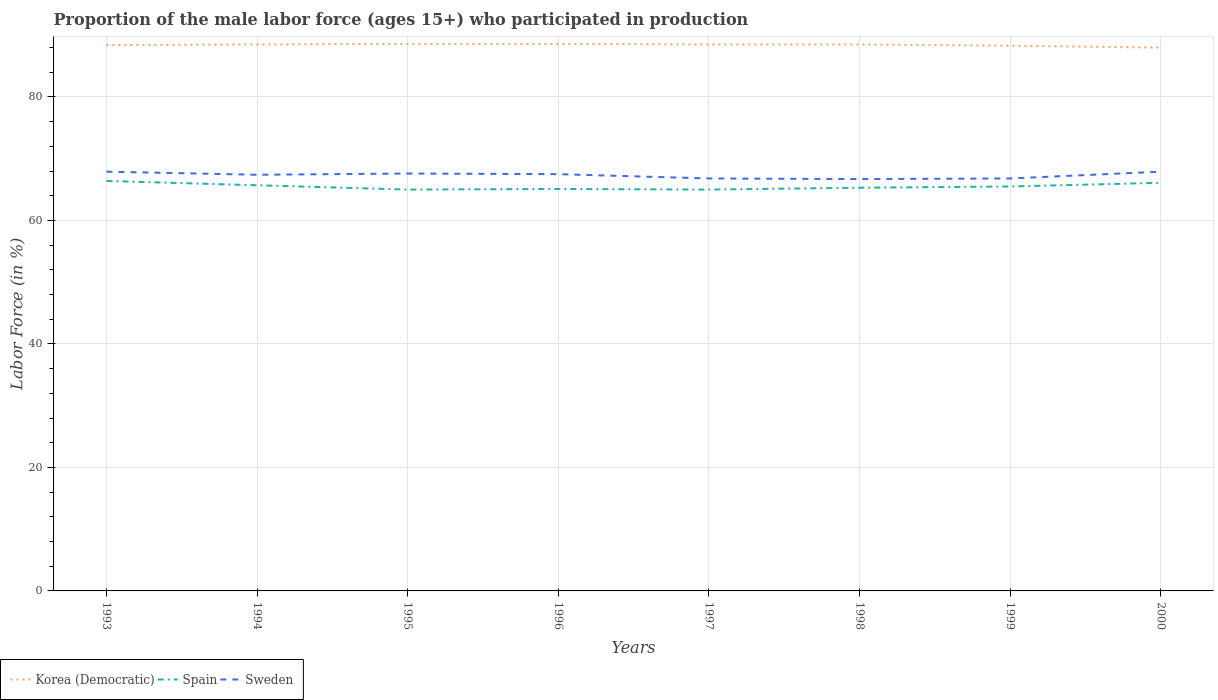Does the line corresponding to Korea (Democratic) intersect with the line corresponding to Spain?
Make the answer very short. No. Across all years, what is the maximum proportion of the male labor force who participated in production in Korea (Democratic)?
Provide a short and direct response. 88. What is the total proportion of the male labor force who participated in production in Korea (Democratic) in the graph?
Offer a terse response. -0.1. What is the difference between the highest and the second highest proportion of the male labor force who participated in production in Korea (Democratic)?
Your response must be concise. 0.6. What is the difference between the highest and the lowest proportion of the male labor force who participated in production in Sweden?
Ensure brevity in your answer.  5. How many lines are there?
Provide a succinct answer. 3. How many years are there in the graph?
Ensure brevity in your answer.  8. What is the difference between two consecutive major ticks on the Y-axis?
Provide a succinct answer. 20. Are the values on the major ticks of Y-axis written in scientific E-notation?
Ensure brevity in your answer.  No. Does the graph contain any zero values?
Offer a terse response. No. How many legend labels are there?
Your answer should be compact. 3. How are the legend labels stacked?
Your answer should be compact. Horizontal. What is the title of the graph?
Keep it short and to the point. Proportion of the male labor force (ages 15+) who participated in production. What is the label or title of the Y-axis?
Offer a terse response. Labor Force (in %). What is the Labor Force (in %) in Korea (Democratic) in 1993?
Offer a very short reply. 88.4. What is the Labor Force (in %) of Spain in 1993?
Keep it short and to the point. 66.4. What is the Labor Force (in %) in Sweden in 1993?
Offer a very short reply. 67.9. What is the Labor Force (in %) in Korea (Democratic) in 1994?
Make the answer very short. 88.5. What is the Labor Force (in %) of Spain in 1994?
Make the answer very short. 65.7. What is the Labor Force (in %) in Sweden in 1994?
Keep it short and to the point. 67.4. What is the Labor Force (in %) of Korea (Democratic) in 1995?
Your answer should be compact. 88.6. What is the Labor Force (in %) in Sweden in 1995?
Offer a terse response. 67.6. What is the Labor Force (in %) in Korea (Democratic) in 1996?
Ensure brevity in your answer.  88.6. What is the Labor Force (in %) in Spain in 1996?
Keep it short and to the point. 65.1. What is the Labor Force (in %) in Sweden in 1996?
Keep it short and to the point. 67.5. What is the Labor Force (in %) of Korea (Democratic) in 1997?
Your answer should be compact. 88.5. What is the Labor Force (in %) of Sweden in 1997?
Ensure brevity in your answer.  66.8. What is the Labor Force (in %) of Korea (Democratic) in 1998?
Provide a short and direct response. 88.5. What is the Labor Force (in %) of Spain in 1998?
Keep it short and to the point. 65.3. What is the Labor Force (in %) in Sweden in 1998?
Ensure brevity in your answer.  66.7. What is the Labor Force (in %) in Korea (Democratic) in 1999?
Give a very brief answer. 88.3. What is the Labor Force (in %) of Spain in 1999?
Your answer should be very brief. 65.5. What is the Labor Force (in %) of Sweden in 1999?
Provide a short and direct response. 66.8. What is the Labor Force (in %) in Korea (Democratic) in 2000?
Offer a very short reply. 88. What is the Labor Force (in %) of Spain in 2000?
Offer a terse response. 66.1. What is the Labor Force (in %) in Sweden in 2000?
Offer a terse response. 67.9. Across all years, what is the maximum Labor Force (in %) of Korea (Democratic)?
Ensure brevity in your answer.  88.6. Across all years, what is the maximum Labor Force (in %) in Spain?
Offer a terse response. 66.4. Across all years, what is the maximum Labor Force (in %) of Sweden?
Give a very brief answer. 67.9. Across all years, what is the minimum Labor Force (in %) in Korea (Democratic)?
Provide a short and direct response. 88. Across all years, what is the minimum Labor Force (in %) in Sweden?
Keep it short and to the point. 66.7. What is the total Labor Force (in %) in Korea (Democratic) in the graph?
Offer a terse response. 707.4. What is the total Labor Force (in %) of Spain in the graph?
Offer a very short reply. 524.1. What is the total Labor Force (in %) in Sweden in the graph?
Your answer should be compact. 538.6. What is the difference between the Labor Force (in %) of Korea (Democratic) in 1993 and that in 1994?
Make the answer very short. -0.1. What is the difference between the Labor Force (in %) in Spain in 1993 and that in 1994?
Make the answer very short. 0.7. What is the difference between the Labor Force (in %) in Spain in 1993 and that in 1995?
Offer a terse response. 1.4. What is the difference between the Labor Force (in %) of Sweden in 1993 and that in 1995?
Ensure brevity in your answer.  0.3. What is the difference between the Labor Force (in %) in Sweden in 1993 and that in 1996?
Your response must be concise. 0.4. What is the difference between the Labor Force (in %) in Spain in 1993 and that in 1997?
Your answer should be very brief. 1.4. What is the difference between the Labor Force (in %) of Sweden in 1993 and that in 1997?
Your answer should be very brief. 1.1. What is the difference between the Labor Force (in %) of Spain in 1993 and that in 1998?
Make the answer very short. 1.1. What is the difference between the Labor Force (in %) in Korea (Democratic) in 1993 and that in 1999?
Provide a short and direct response. 0.1. What is the difference between the Labor Force (in %) in Spain in 1993 and that in 1999?
Your response must be concise. 0.9. What is the difference between the Labor Force (in %) of Sweden in 1993 and that in 1999?
Provide a short and direct response. 1.1. What is the difference between the Labor Force (in %) of Sweden in 1993 and that in 2000?
Provide a short and direct response. 0. What is the difference between the Labor Force (in %) in Spain in 1994 and that in 1995?
Offer a terse response. 0.7. What is the difference between the Labor Force (in %) in Korea (Democratic) in 1994 and that in 1996?
Keep it short and to the point. -0.1. What is the difference between the Labor Force (in %) of Spain in 1994 and that in 1996?
Offer a very short reply. 0.6. What is the difference between the Labor Force (in %) in Korea (Democratic) in 1994 and that in 1997?
Provide a succinct answer. 0. What is the difference between the Labor Force (in %) in Spain in 1994 and that in 1997?
Ensure brevity in your answer.  0.7. What is the difference between the Labor Force (in %) in Sweden in 1994 and that in 1997?
Provide a succinct answer. 0.6. What is the difference between the Labor Force (in %) of Korea (Democratic) in 1994 and that in 1998?
Your answer should be very brief. 0. What is the difference between the Labor Force (in %) of Spain in 1994 and that in 1998?
Provide a succinct answer. 0.4. What is the difference between the Labor Force (in %) of Spain in 1994 and that in 1999?
Keep it short and to the point. 0.2. What is the difference between the Labor Force (in %) in Sweden in 1994 and that in 1999?
Keep it short and to the point. 0.6. What is the difference between the Labor Force (in %) of Spain in 1995 and that in 1996?
Your answer should be compact. -0.1. What is the difference between the Labor Force (in %) in Sweden in 1995 and that in 1996?
Ensure brevity in your answer.  0.1. What is the difference between the Labor Force (in %) of Spain in 1995 and that in 1997?
Offer a terse response. 0. What is the difference between the Labor Force (in %) of Korea (Democratic) in 1995 and that in 1998?
Offer a terse response. 0.1. What is the difference between the Labor Force (in %) of Spain in 1995 and that in 1998?
Your response must be concise. -0.3. What is the difference between the Labor Force (in %) in Korea (Democratic) in 1995 and that in 1999?
Provide a short and direct response. 0.3. What is the difference between the Labor Force (in %) in Sweden in 1995 and that in 1999?
Provide a short and direct response. 0.8. What is the difference between the Labor Force (in %) in Korea (Democratic) in 1995 and that in 2000?
Your answer should be compact. 0.6. What is the difference between the Labor Force (in %) of Sweden in 1995 and that in 2000?
Give a very brief answer. -0.3. What is the difference between the Labor Force (in %) in Spain in 1996 and that in 1997?
Ensure brevity in your answer.  0.1. What is the difference between the Labor Force (in %) in Korea (Democratic) in 1996 and that in 1998?
Your response must be concise. 0.1. What is the difference between the Labor Force (in %) in Spain in 1996 and that in 1998?
Offer a terse response. -0.2. What is the difference between the Labor Force (in %) of Sweden in 1996 and that in 1998?
Keep it short and to the point. 0.8. What is the difference between the Labor Force (in %) of Sweden in 1996 and that in 1999?
Offer a very short reply. 0.7. What is the difference between the Labor Force (in %) of Korea (Democratic) in 1996 and that in 2000?
Make the answer very short. 0.6. What is the difference between the Labor Force (in %) in Spain in 1996 and that in 2000?
Offer a very short reply. -1. What is the difference between the Labor Force (in %) of Korea (Democratic) in 1997 and that in 1998?
Keep it short and to the point. 0. What is the difference between the Labor Force (in %) of Sweden in 1997 and that in 1999?
Ensure brevity in your answer.  0. What is the difference between the Labor Force (in %) of Korea (Democratic) in 1998 and that in 1999?
Your answer should be compact. 0.2. What is the difference between the Labor Force (in %) of Spain in 1998 and that in 1999?
Your answer should be very brief. -0.2. What is the difference between the Labor Force (in %) in Sweden in 1998 and that in 2000?
Keep it short and to the point. -1.2. What is the difference between the Labor Force (in %) of Korea (Democratic) in 1999 and that in 2000?
Make the answer very short. 0.3. What is the difference between the Labor Force (in %) in Sweden in 1999 and that in 2000?
Ensure brevity in your answer.  -1.1. What is the difference between the Labor Force (in %) of Korea (Democratic) in 1993 and the Labor Force (in %) of Spain in 1994?
Give a very brief answer. 22.7. What is the difference between the Labor Force (in %) in Korea (Democratic) in 1993 and the Labor Force (in %) in Sweden in 1994?
Your answer should be compact. 21. What is the difference between the Labor Force (in %) of Korea (Democratic) in 1993 and the Labor Force (in %) of Spain in 1995?
Give a very brief answer. 23.4. What is the difference between the Labor Force (in %) in Korea (Democratic) in 1993 and the Labor Force (in %) in Sweden in 1995?
Offer a very short reply. 20.8. What is the difference between the Labor Force (in %) in Korea (Democratic) in 1993 and the Labor Force (in %) in Spain in 1996?
Make the answer very short. 23.3. What is the difference between the Labor Force (in %) of Korea (Democratic) in 1993 and the Labor Force (in %) of Sweden in 1996?
Keep it short and to the point. 20.9. What is the difference between the Labor Force (in %) in Korea (Democratic) in 1993 and the Labor Force (in %) in Spain in 1997?
Give a very brief answer. 23.4. What is the difference between the Labor Force (in %) in Korea (Democratic) in 1993 and the Labor Force (in %) in Sweden in 1997?
Offer a terse response. 21.6. What is the difference between the Labor Force (in %) of Spain in 1993 and the Labor Force (in %) of Sweden in 1997?
Your answer should be compact. -0.4. What is the difference between the Labor Force (in %) of Korea (Democratic) in 1993 and the Labor Force (in %) of Spain in 1998?
Provide a short and direct response. 23.1. What is the difference between the Labor Force (in %) of Korea (Democratic) in 1993 and the Labor Force (in %) of Sweden in 1998?
Offer a terse response. 21.7. What is the difference between the Labor Force (in %) in Spain in 1993 and the Labor Force (in %) in Sweden in 1998?
Give a very brief answer. -0.3. What is the difference between the Labor Force (in %) in Korea (Democratic) in 1993 and the Labor Force (in %) in Spain in 1999?
Your answer should be very brief. 22.9. What is the difference between the Labor Force (in %) in Korea (Democratic) in 1993 and the Labor Force (in %) in Sweden in 1999?
Your answer should be very brief. 21.6. What is the difference between the Labor Force (in %) of Spain in 1993 and the Labor Force (in %) of Sweden in 1999?
Offer a very short reply. -0.4. What is the difference between the Labor Force (in %) in Korea (Democratic) in 1993 and the Labor Force (in %) in Spain in 2000?
Your answer should be very brief. 22.3. What is the difference between the Labor Force (in %) of Korea (Democratic) in 1994 and the Labor Force (in %) of Spain in 1995?
Offer a terse response. 23.5. What is the difference between the Labor Force (in %) of Korea (Democratic) in 1994 and the Labor Force (in %) of Sweden in 1995?
Your answer should be compact. 20.9. What is the difference between the Labor Force (in %) in Korea (Democratic) in 1994 and the Labor Force (in %) in Spain in 1996?
Give a very brief answer. 23.4. What is the difference between the Labor Force (in %) in Korea (Democratic) in 1994 and the Labor Force (in %) in Spain in 1997?
Give a very brief answer. 23.5. What is the difference between the Labor Force (in %) of Korea (Democratic) in 1994 and the Labor Force (in %) of Sweden in 1997?
Your response must be concise. 21.7. What is the difference between the Labor Force (in %) of Korea (Democratic) in 1994 and the Labor Force (in %) of Spain in 1998?
Your answer should be very brief. 23.2. What is the difference between the Labor Force (in %) of Korea (Democratic) in 1994 and the Labor Force (in %) of Sweden in 1998?
Offer a terse response. 21.8. What is the difference between the Labor Force (in %) of Spain in 1994 and the Labor Force (in %) of Sweden in 1998?
Ensure brevity in your answer.  -1. What is the difference between the Labor Force (in %) in Korea (Democratic) in 1994 and the Labor Force (in %) in Spain in 1999?
Your answer should be compact. 23. What is the difference between the Labor Force (in %) of Korea (Democratic) in 1994 and the Labor Force (in %) of Sweden in 1999?
Provide a succinct answer. 21.7. What is the difference between the Labor Force (in %) in Spain in 1994 and the Labor Force (in %) in Sweden in 1999?
Your answer should be compact. -1.1. What is the difference between the Labor Force (in %) of Korea (Democratic) in 1994 and the Labor Force (in %) of Spain in 2000?
Make the answer very short. 22.4. What is the difference between the Labor Force (in %) of Korea (Democratic) in 1994 and the Labor Force (in %) of Sweden in 2000?
Offer a very short reply. 20.6. What is the difference between the Labor Force (in %) in Korea (Democratic) in 1995 and the Labor Force (in %) in Spain in 1996?
Provide a short and direct response. 23.5. What is the difference between the Labor Force (in %) in Korea (Democratic) in 1995 and the Labor Force (in %) in Sweden in 1996?
Make the answer very short. 21.1. What is the difference between the Labor Force (in %) of Spain in 1995 and the Labor Force (in %) of Sweden in 1996?
Your response must be concise. -2.5. What is the difference between the Labor Force (in %) of Korea (Democratic) in 1995 and the Labor Force (in %) of Spain in 1997?
Make the answer very short. 23.6. What is the difference between the Labor Force (in %) of Korea (Democratic) in 1995 and the Labor Force (in %) of Sweden in 1997?
Make the answer very short. 21.8. What is the difference between the Labor Force (in %) of Korea (Democratic) in 1995 and the Labor Force (in %) of Spain in 1998?
Keep it short and to the point. 23.3. What is the difference between the Labor Force (in %) in Korea (Democratic) in 1995 and the Labor Force (in %) in Sweden in 1998?
Keep it short and to the point. 21.9. What is the difference between the Labor Force (in %) in Korea (Democratic) in 1995 and the Labor Force (in %) in Spain in 1999?
Provide a short and direct response. 23.1. What is the difference between the Labor Force (in %) of Korea (Democratic) in 1995 and the Labor Force (in %) of Sweden in 1999?
Provide a short and direct response. 21.8. What is the difference between the Labor Force (in %) of Spain in 1995 and the Labor Force (in %) of Sweden in 1999?
Provide a short and direct response. -1.8. What is the difference between the Labor Force (in %) in Korea (Democratic) in 1995 and the Labor Force (in %) in Sweden in 2000?
Your response must be concise. 20.7. What is the difference between the Labor Force (in %) in Korea (Democratic) in 1996 and the Labor Force (in %) in Spain in 1997?
Your answer should be very brief. 23.6. What is the difference between the Labor Force (in %) of Korea (Democratic) in 1996 and the Labor Force (in %) of Sweden in 1997?
Your answer should be compact. 21.8. What is the difference between the Labor Force (in %) of Korea (Democratic) in 1996 and the Labor Force (in %) of Spain in 1998?
Your response must be concise. 23.3. What is the difference between the Labor Force (in %) of Korea (Democratic) in 1996 and the Labor Force (in %) of Sweden in 1998?
Offer a terse response. 21.9. What is the difference between the Labor Force (in %) of Spain in 1996 and the Labor Force (in %) of Sweden in 1998?
Offer a terse response. -1.6. What is the difference between the Labor Force (in %) in Korea (Democratic) in 1996 and the Labor Force (in %) in Spain in 1999?
Make the answer very short. 23.1. What is the difference between the Labor Force (in %) in Korea (Democratic) in 1996 and the Labor Force (in %) in Sweden in 1999?
Make the answer very short. 21.8. What is the difference between the Labor Force (in %) in Spain in 1996 and the Labor Force (in %) in Sweden in 1999?
Provide a succinct answer. -1.7. What is the difference between the Labor Force (in %) of Korea (Democratic) in 1996 and the Labor Force (in %) of Sweden in 2000?
Offer a terse response. 20.7. What is the difference between the Labor Force (in %) of Spain in 1996 and the Labor Force (in %) of Sweden in 2000?
Keep it short and to the point. -2.8. What is the difference between the Labor Force (in %) of Korea (Democratic) in 1997 and the Labor Force (in %) of Spain in 1998?
Make the answer very short. 23.2. What is the difference between the Labor Force (in %) in Korea (Democratic) in 1997 and the Labor Force (in %) in Sweden in 1998?
Provide a succinct answer. 21.8. What is the difference between the Labor Force (in %) of Korea (Democratic) in 1997 and the Labor Force (in %) of Spain in 1999?
Keep it short and to the point. 23. What is the difference between the Labor Force (in %) of Korea (Democratic) in 1997 and the Labor Force (in %) of Sweden in 1999?
Your answer should be compact. 21.7. What is the difference between the Labor Force (in %) in Spain in 1997 and the Labor Force (in %) in Sweden in 1999?
Give a very brief answer. -1.8. What is the difference between the Labor Force (in %) in Korea (Democratic) in 1997 and the Labor Force (in %) in Spain in 2000?
Provide a succinct answer. 22.4. What is the difference between the Labor Force (in %) of Korea (Democratic) in 1997 and the Labor Force (in %) of Sweden in 2000?
Offer a very short reply. 20.6. What is the difference between the Labor Force (in %) in Korea (Democratic) in 1998 and the Labor Force (in %) in Spain in 1999?
Ensure brevity in your answer.  23. What is the difference between the Labor Force (in %) in Korea (Democratic) in 1998 and the Labor Force (in %) in Sweden in 1999?
Ensure brevity in your answer.  21.7. What is the difference between the Labor Force (in %) of Spain in 1998 and the Labor Force (in %) of Sweden in 1999?
Give a very brief answer. -1.5. What is the difference between the Labor Force (in %) of Korea (Democratic) in 1998 and the Labor Force (in %) of Spain in 2000?
Provide a succinct answer. 22.4. What is the difference between the Labor Force (in %) in Korea (Democratic) in 1998 and the Labor Force (in %) in Sweden in 2000?
Ensure brevity in your answer.  20.6. What is the difference between the Labor Force (in %) in Korea (Democratic) in 1999 and the Labor Force (in %) in Spain in 2000?
Keep it short and to the point. 22.2. What is the difference between the Labor Force (in %) in Korea (Democratic) in 1999 and the Labor Force (in %) in Sweden in 2000?
Make the answer very short. 20.4. What is the difference between the Labor Force (in %) in Spain in 1999 and the Labor Force (in %) in Sweden in 2000?
Make the answer very short. -2.4. What is the average Labor Force (in %) in Korea (Democratic) per year?
Provide a succinct answer. 88.42. What is the average Labor Force (in %) in Spain per year?
Ensure brevity in your answer.  65.51. What is the average Labor Force (in %) in Sweden per year?
Provide a short and direct response. 67.33. In the year 1993, what is the difference between the Labor Force (in %) in Korea (Democratic) and Labor Force (in %) in Spain?
Provide a succinct answer. 22. In the year 1994, what is the difference between the Labor Force (in %) of Korea (Democratic) and Labor Force (in %) of Spain?
Provide a short and direct response. 22.8. In the year 1994, what is the difference between the Labor Force (in %) in Korea (Democratic) and Labor Force (in %) in Sweden?
Keep it short and to the point. 21.1. In the year 1995, what is the difference between the Labor Force (in %) in Korea (Democratic) and Labor Force (in %) in Spain?
Offer a terse response. 23.6. In the year 1995, what is the difference between the Labor Force (in %) in Spain and Labor Force (in %) in Sweden?
Your response must be concise. -2.6. In the year 1996, what is the difference between the Labor Force (in %) of Korea (Democratic) and Labor Force (in %) of Sweden?
Make the answer very short. 21.1. In the year 1997, what is the difference between the Labor Force (in %) in Korea (Democratic) and Labor Force (in %) in Spain?
Your response must be concise. 23.5. In the year 1997, what is the difference between the Labor Force (in %) of Korea (Democratic) and Labor Force (in %) of Sweden?
Your answer should be very brief. 21.7. In the year 1998, what is the difference between the Labor Force (in %) of Korea (Democratic) and Labor Force (in %) of Spain?
Ensure brevity in your answer.  23.2. In the year 1998, what is the difference between the Labor Force (in %) of Korea (Democratic) and Labor Force (in %) of Sweden?
Ensure brevity in your answer.  21.8. In the year 1998, what is the difference between the Labor Force (in %) of Spain and Labor Force (in %) of Sweden?
Make the answer very short. -1.4. In the year 1999, what is the difference between the Labor Force (in %) of Korea (Democratic) and Labor Force (in %) of Spain?
Ensure brevity in your answer.  22.8. In the year 1999, what is the difference between the Labor Force (in %) of Spain and Labor Force (in %) of Sweden?
Make the answer very short. -1.3. In the year 2000, what is the difference between the Labor Force (in %) in Korea (Democratic) and Labor Force (in %) in Spain?
Provide a succinct answer. 21.9. In the year 2000, what is the difference between the Labor Force (in %) of Korea (Democratic) and Labor Force (in %) of Sweden?
Your answer should be compact. 20.1. What is the ratio of the Labor Force (in %) in Korea (Democratic) in 1993 to that in 1994?
Offer a terse response. 1. What is the ratio of the Labor Force (in %) in Spain in 1993 to that in 1994?
Make the answer very short. 1.01. What is the ratio of the Labor Force (in %) of Sweden in 1993 to that in 1994?
Your answer should be very brief. 1.01. What is the ratio of the Labor Force (in %) of Spain in 1993 to that in 1995?
Provide a succinct answer. 1.02. What is the ratio of the Labor Force (in %) of Sweden in 1993 to that in 1995?
Your answer should be very brief. 1. What is the ratio of the Labor Force (in %) in Spain in 1993 to that in 1996?
Keep it short and to the point. 1.02. What is the ratio of the Labor Force (in %) in Sweden in 1993 to that in 1996?
Give a very brief answer. 1.01. What is the ratio of the Labor Force (in %) of Spain in 1993 to that in 1997?
Your response must be concise. 1.02. What is the ratio of the Labor Force (in %) in Sweden in 1993 to that in 1997?
Offer a very short reply. 1.02. What is the ratio of the Labor Force (in %) of Spain in 1993 to that in 1998?
Provide a succinct answer. 1.02. What is the ratio of the Labor Force (in %) of Korea (Democratic) in 1993 to that in 1999?
Offer a very short reply. 1. What is the ratio of the Labor Force (in %) of Spain in 1993 to that in 1999?
Give a very brief answer. 1.01. What is the ratio of the Labor Force (in %) in Sweden in 1993 to that in 1999?
Your answer should be very brief. 1.02. What is the ratio of the Labor Force (in %) of Korea (Democratic) in 1993 to that in 2000?
Keep it short and to the point. 1. What is the ratio of the Labor Force (in %) in Spain in 1993 to that in 2000?
Offer a terse response. 1. What is the ratio of the Labor Force (in %) of Sweden in 1993 to that in 2000?
Your response must be concise. 1. What is the ratio of the Labor Force (in %) of Korea (Democratic) in 1994 to that in 1995?
Your response must be concise. 1. What is the ratio of the Labor Force (in %) in Spain in 1994 to that in 1995?
Provide a short and direct response. 1.01. What is the ratio of the Labor Force (in %) in Sweden in 1994 to that in 1995?
Offer a very short reply. 1. What is the ratio of the Labor Force (in %) of Spain in 1994 to that in 1996?
Offer a terse response. 1.01. What is the ratio of the Labor Force (in %) in Spain in 1994 to that in 1997?
Your answer should be very brief. 1.01. What is the ratio of the Labor Force (in %) in Sweden in 1994 to that in 1997?
Your answer should be compact. 1.01. What is the ratio of the Labor Force (in %) in Sweden in 1994 to that in 1998?
Offer a very short reply. 1.01. What is the ratio of the Labor Force (in %) of Korea (Democratic) in 1994 to that in 1999?
Make the answer very short. 1. What is the ratio of the Labor Force (in %) in Sweden in 1994 to that in 2000?
Give a very brief answer. 0.99. What is the ratio of the Labor Force (in %) of Spain in 1995 to that in 1996?
Provide a short and direct response. 1. What is the ratio of the Labor Force (in %) in Sweden in 1995 to that in 1996?
Offer a terse response. 1. What is the ratio of the Labor Force (in %) of Spain in 1995 to that in 1997?
Make the answer very short. 1. What is the ratio of the Labor Force (in %) in Sweden in 1995 to that in 1997?
Offer a very short reply. 1.01. What is the ratio of the Labor Force (in %) in Korea (Democratic) in 1995 to that in 1998?
Make the answer very short. 1. What is the ratio of the Labor Force (in %) of Spain in 1995 to that in 1998?
Your answer should be very brief. 1. What is the ratio of the Labor Force (in %) in Sweden in 1995 to that in 1998?
Your response must be concise. 1.01. What is the ratio of the Labor Force (in %) in Korea (Democratic) in 1995 to that in 1999?
Offer a very short reply. 1. What is the ratio of the Labor Force (in %) of Spain in 1995 to that in 1999?
Your response must be concise. 0.99. What is the ratio of the Labor Force (in %) of Sweden in 1995 to that in 1999?
Keep it short and to the point. 1.01. What is the ratio of the Labor Force (in %) of Korea (Democratic) in 1995 to that in 2000?
Your response must be concise. 1.01. What is the ratio of the Labor Force (in %) in Spain in 1995 to that in 2000?
Your response must be concise. 0.98. What is the ratio of the Labor Force (in %) of Korea (Democratic) in 1996 to that in 1997?
Your answer should be very brief. 1. What is the ratio of the Labor Force (in %) of Sweden in 1996 to that in 1997?
Your answer should be very brief. 1.01. What is the ratio of the Labor Force (in %) of Korea (Democratic) in 1996 to that in 1998?
Provide a succinct answer. 1. What is the ratio of the Labor Force (in %) in Korea (Democratic) in 1996 to that in 1999?
Offer a very short reply. 1. What is the ratio of the Labor Force (in %) in Spain in 1996 to that in 1999?
Your answer should be very brief. 0.99. What is the ratio of the Labor Force (in %) in Sweden in 1996 to that in 1999?
Ensure brevity in your answer.  1.01. What is the ratio of the Labor Force (in %) in Korea (Democratic) in 1996 to that in 2000?
Your answer should be very brief. 1.01. What is the ratio of the Labor Force (in %) of Spain in 1996 to that in 2000?
Your answer should be very brief. 0.98. What is the ratio of the Labor Force (in %) in Sweden in 1996 to that in 2000?
Your response must be concise. 0.99. What is the ratio of the Labor Force (in %) in Korea (Democratic) in 1997 to that in 1998?
Your answer should be very brief. 1. What is the ratio of the Labor Force (in %) of Spain in 1997 to that in 1998?
Keep it short and to the point. 1. What is the ratio of the Labor Force (in %) in Sweden in 1997 to that in 1998?
Offer a terse response. 1. What is the ratio of the Labor Force (in %) in Sweden in 1997 to that in 1999?
Your answer should be compact. 1. What is the ratio of the Labor Force (in %) of Spain in 1997 to that in 2000?
Make the answer very short. 0.98. What is the ratio of the Labor Force (in %) in Sweden in 1997 to that in 2000?
Your answer should be compact. 0.98. What is the ratio of the Labor Force (in %) of Korea (Democratic) in 1998 to that in 1999?
Ensure brevity in your answer.  1. What is the ratio of the Labor Force (in %) of Spain in 1998 to that in 1999?
Offer a terse response. 1. What is the ratio of the Labor Force (in %) of Sweden in 1998 to that in 1999?
Ensure brevity in your answer.  1. What is the ratio of the Labor Force (in %) in Spain in 1998 to that in 2000?
Your answer should be very brief. 0.99. What is the ratio of the Labor Force (in %) in Sweden in 1998 to that in 2000?
Make the answer very short. 0.98. What is the ratio of the Labor Force (in %) of Spain in 1999 to that in 2000?
Ensure brevity in your answer.  0.99. What is the ratio of the Labor Force (in %) of Sweden in 1999 to that in 2000?
Keep it short and to the point. 0.98. What is the difference between the highest and the second highest Labor Force (in %) of Korea (Democratic)?
Your answer should be compact. 0. What is the difference between the highest and the lowest Labor Force (in %) of Spain?
Ensure brevity in your answer.  1.4. 